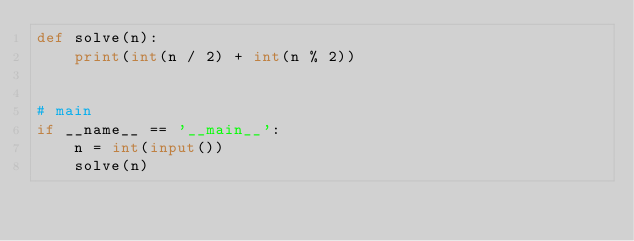Convert code to text. <code><loc_0><loc_0><loc_500><loc_500><_Python_>def solve(n):
    print(int(n / 2) + int(n % 2))


# main
if __name__ == '__main__':
    n = int(input())
    solve(n)
</code> 